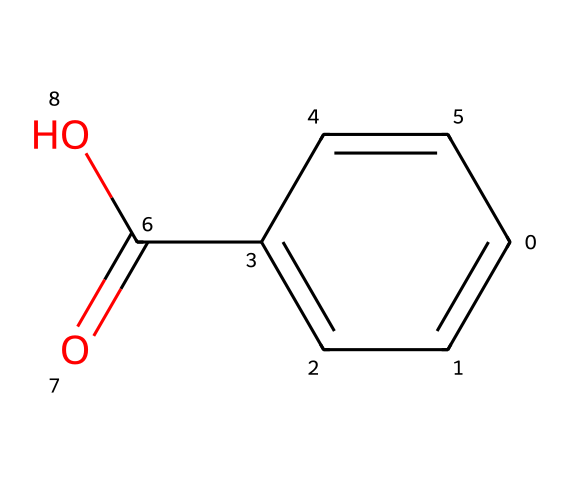What is the IUPAC name of this compound? The SMILES representation indicates that the compound has a carboxylic acid functional group and an aromatic ring. If we analyze the structure, we can determine that it is benzoic acid, where "benzo" refers to the benzene ring and "ic acid" denotes the presence of the carboxylic acid group.
Answer: benzoic acid How many carbon atoms are in this molecule? The SMILES representation can be broken down into individual components. Counting the carbon atoms in the structure shows that there are seven carbon atoms in total.
Answer: 7 What type of functional group is present in this structure? The presence of the -COOH group (as seen in the "C(=O)O" part of the SMILES) indicates that this molecule contains a carboxylic acid functional group.
Answer: carboxylic acid How many double bonds are in the molecule? Analyzing the chemical structure from the SMILES, we can identify that there is one double bond between the carbon and oxygen in the carboxyl group and three double bonds in the aromatic ring. Therefore, a total of four double bonds are present.
Answer: 4 Is this compound soluble in water? Benzoic acid is known to be moderately soluble in water due to its polar carboxylic acid group, although it has a largely non-polar benzene ring, contributing to limited solubility. Generally, it is considered soluble at higher temperatures.
Answer: moderately soluble What role does this compound play in cosmetics? As a preservative, benzoic acid is commonly used in cosmetics to inhibit microbial growth, thereby extending the shelf life of products. Its ability to prevent degradation from bacteria and mold is crucial in cosmetic formulations.
Answer: preservative 